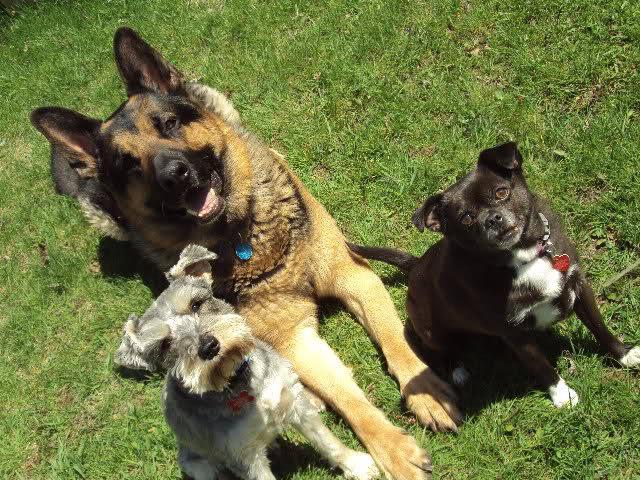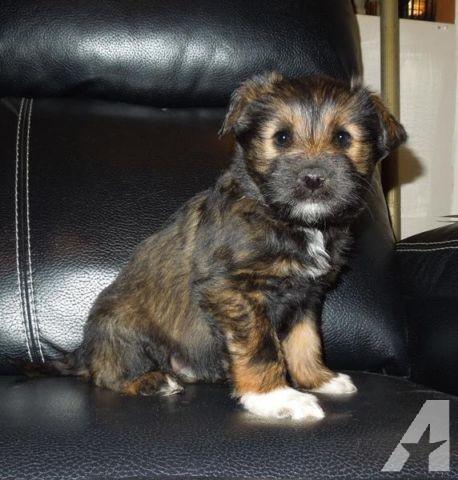The first image is the image on the left, the second image is the image on the right. Analyze the images presented: Is the assertion "At least four dogs are visible." valid? Answer yes or no. Yes. The first image is the image on the left, the second image is the image on the right. Analyze the images presented: Is the assertion "A puppy is standing up, and an adult dog is lying down." valid? Answer yes or no. No. 